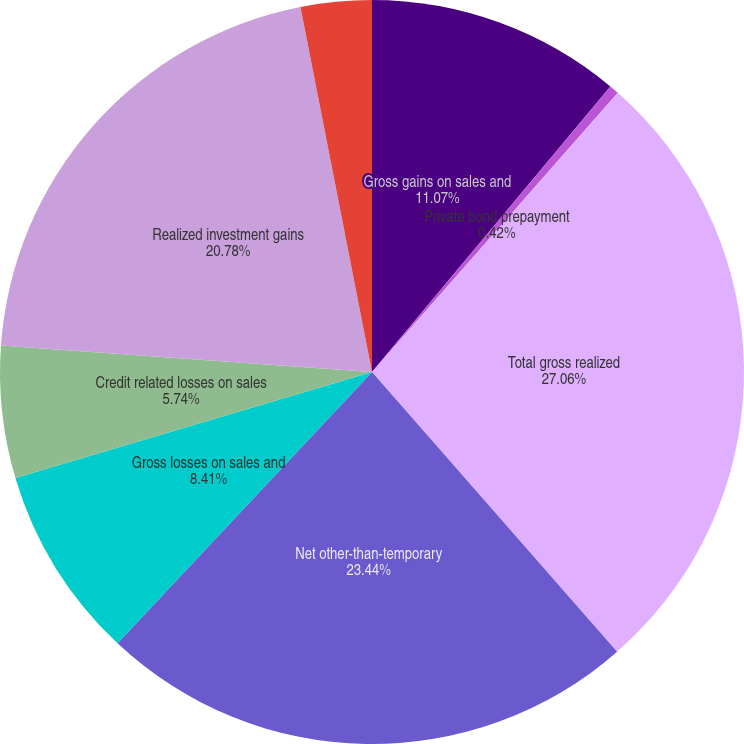Convert chart. <chart><loc_0><loc_0><loc_500><loc_500><pie_chart><fcel>Gross gains on sales and<fcel>Private bond prepayment<fcel>Total gross realized<fcel>Net other-than-temporary<fcel>Gross losses on sales and<fcel>Credit related losses on sales<fcel>Realized investment gains<fcel>Net gains (losses) on sales<nl><fcel>11.07%<fcel>0.42%<fcel>27.06%<fcel>23.44%<fcel>8.41%<fcel>5.74%<fcel>20.78%<fcel>3.08%<nl></chart> 